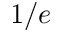<formula> <loc_0><loc_0><loc_500><loc_500>1 / e</formula> 